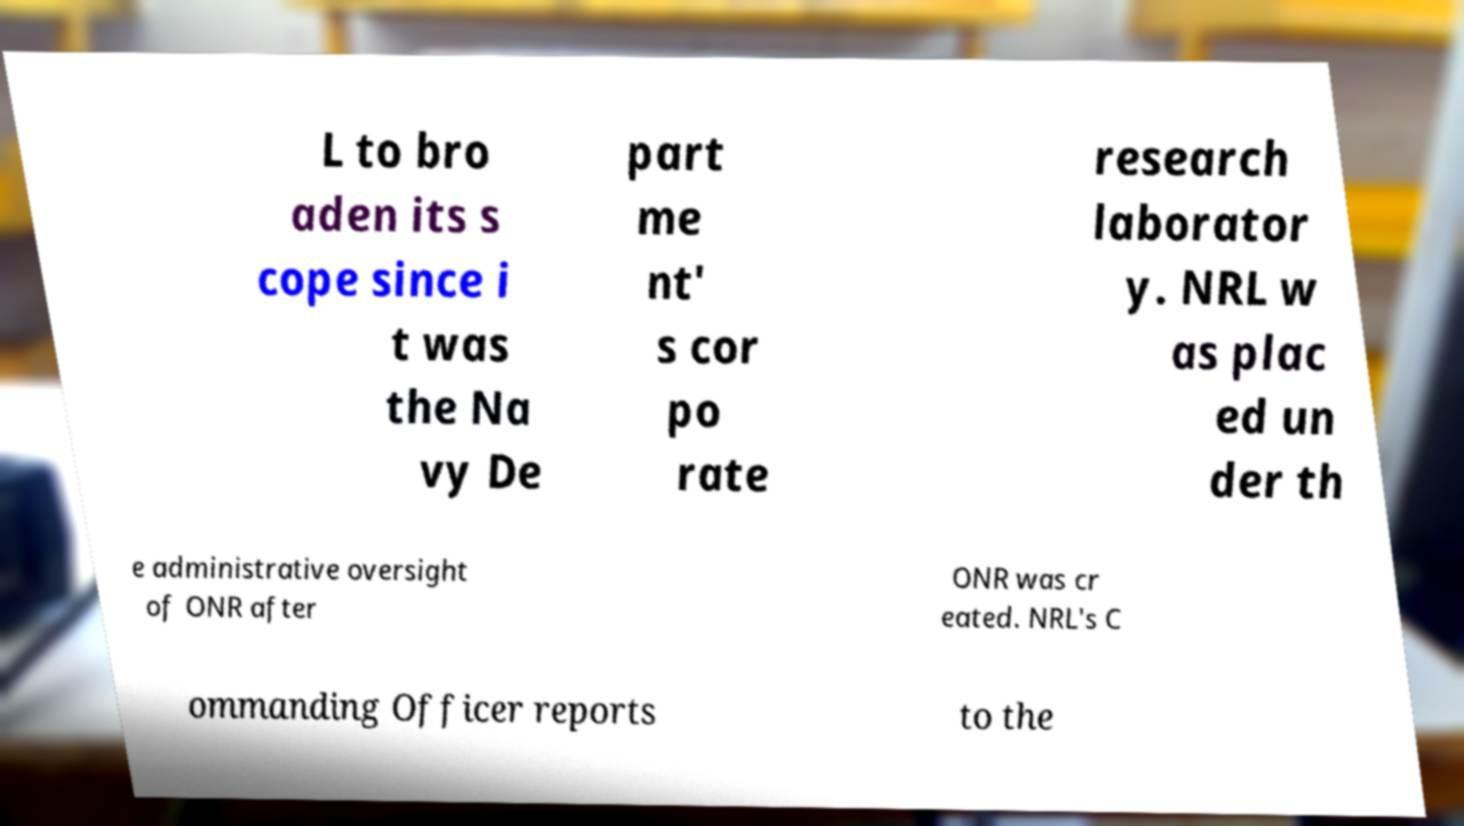Can you accurately transcribe the text from the provided image for me? L to bro aden its s cope since i t was the Na vy De part me nt' s cor po rate research laborator y. NRL w as plac ed un der th e administrative oversight of ONR after ONR was cr eated. NRL's C ommanding Officer reports to the 